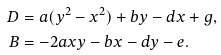Convert formula to latex. <formula><loc_0><loc_0><loc_500><loc_500>D & = a ( y ^ { 2 } - x ^ { 2 } ) + b y - d x + g , \\ B & = - 2 a x y - b x - d y - e .</formula> 